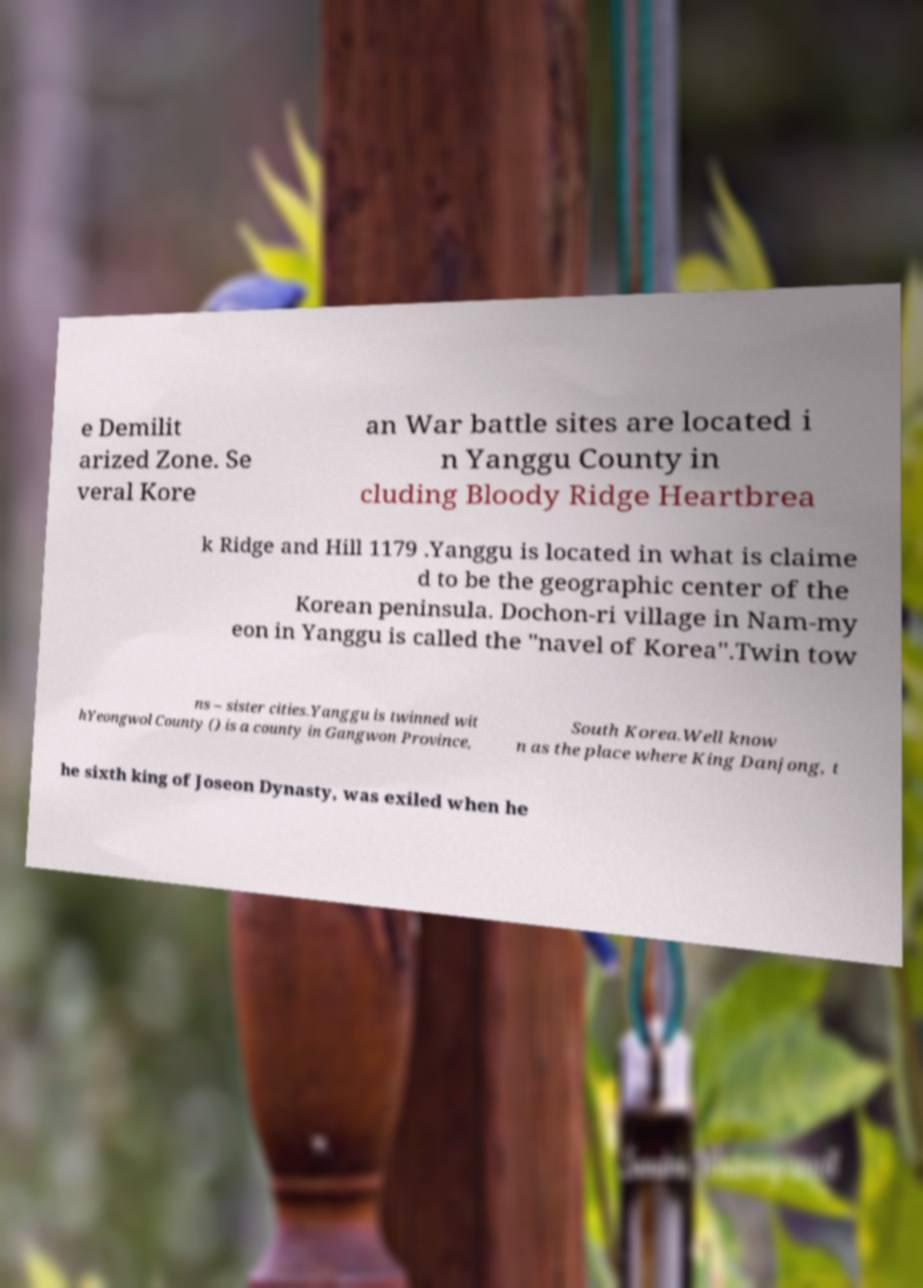There's text embedded in this image that I need extracted. Can you transcribe it verbatim? e Demilit arized Zone. Se veral Kore an War battle sites are located i n Yanggu County in cluding Bloody Ridge Heartbrea k Ridge and Hill 1179 .Yanggu is located in what is claime d to be the geographic center of the Korean peninsula. Dochon-ri village in Nam-my eon in Yanggu is called the "navel of Korea".Twin tow ns – sister cities.Yanggu is twinned wit hYeongwol County () is a county in Gangwon Province, South Korea.Well know n as the place where King Danjong, t he sixth king of Joseon Dynasty, was exiled when he 